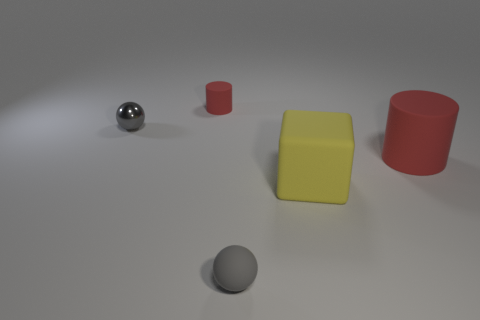Is there anything else that has the same shape as the large yellow rubber object?
Give a very brief answer. No. There is a tiny metal object; is it the same shape as the tiny rubber object that is behind the metallic thing?
Give a very brief answer. No. Is the number of gray balls that are in front of the yellow cube the same as the number of large red matte things that are on the left side of the gray metal object?
Keep it short and to the point. No. How many other things are there of the same material as the large yellow block?
Your answer should be compact. 3. How many metallic things are either tiny red cylinders or blocks?
Offer a very short reply. 0. There is a red thing that is behind the big red matte cylinder; is its shape the same as the large red matte object?
Keep it short and to the point. Yes. Are there more blocks on the right side of the big matte cylinder than small red blocks?
Offer a terse response. No. How many small objects are on the left side of the tiny gray rubber sphere and in front of the tiny cylinder?
Your answer should be compact. 1. There is a ball that is on the left side of the gray thing right of the small shiny thing; what color is it?
Give a very brief answer. Gray. What number of tiny rubber balls are the same color as the shiny sphere?
Offer a terse response. 1. 